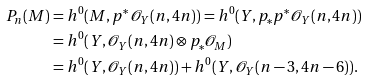Convert formula to latex. <formula><loc_0><loc_0><loc_500><loc_500>P _ { n } ( M ) & = h ^ { 0 } ( M , p ^ { * } { \mathcal { O } } _ { Y } ( n , 4 n ) ) = h ^ { 0 } ( Y , p _ { * } p ^ { * } { \mathcal { O } } _ { Y } ( n , 4 n ) ) \\ & = h ^ { 0 } ( Y , { \mathcal { O } } _ { Y } ( n , 4 n ) \otimes p _ { * } { \mathcal { O } } _ { M } ) \\ & = h ^ { 0 } ( Y , { \mathcal { O } } _ { Y } ( n , 4 n ) ) + h ^ { 0 } ( Y , { \mathcal { O } } _ { Y } ( n - 3 , 4 n - 6 ) ) .</formula> 